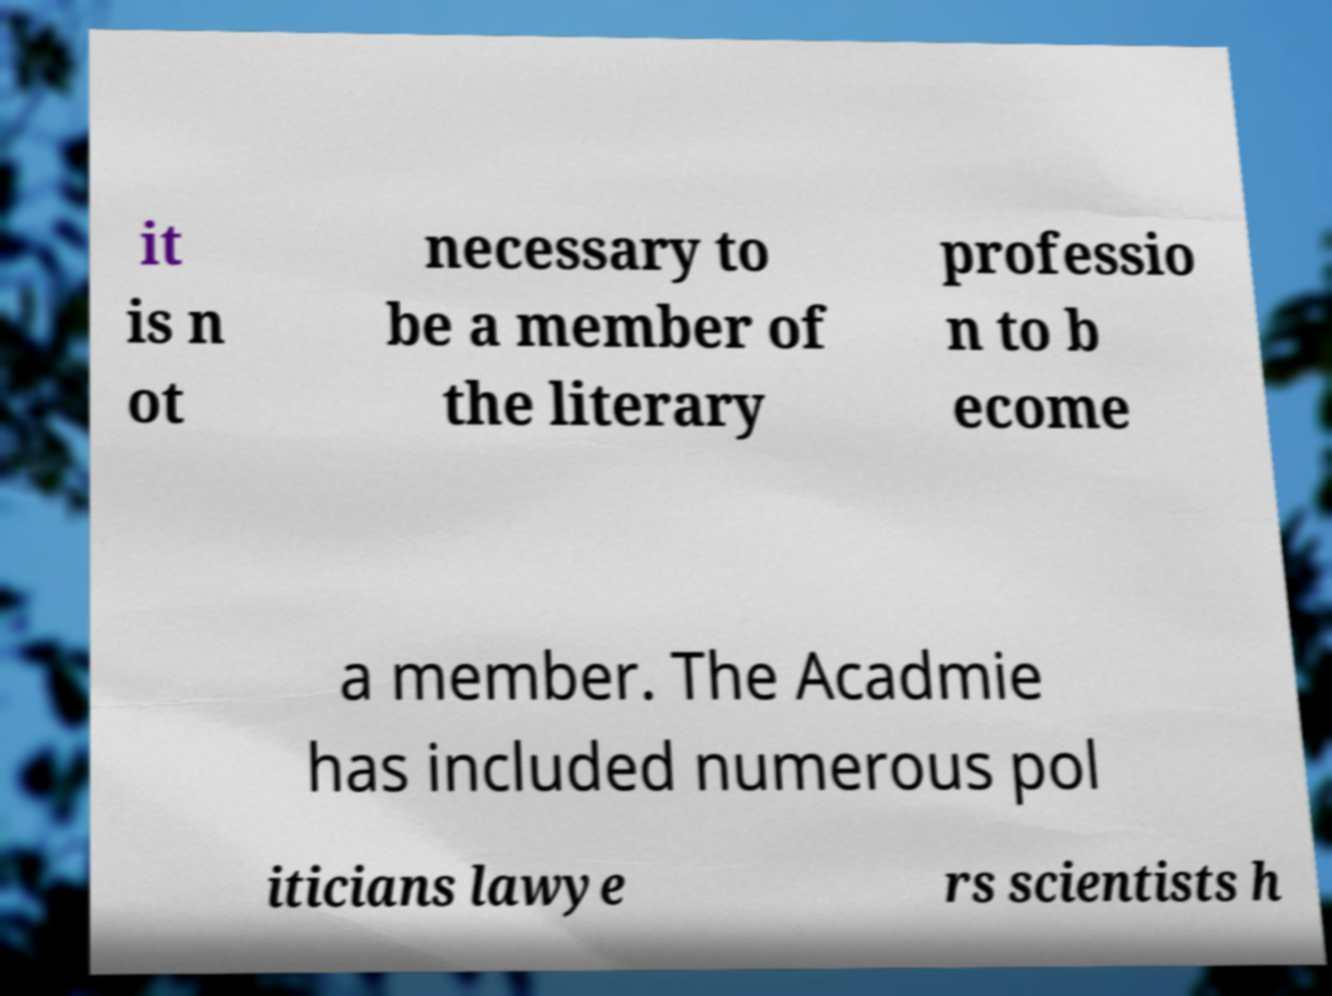I need the written content from this picture converted into text. Can you do that? it is n ot necessary to be a member of the literary professio n to b ecome a member. The Acadmie has included numerous pol iticians lawye rs scientists h 